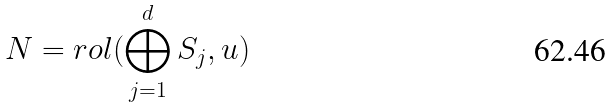Convert formula to latex. <formula><loc_0><loc_0><loc_500><loc_500>N = r o l ( \bigoplus _ { j = 1 } ^ { d } S _ { j } , u )</formula> 